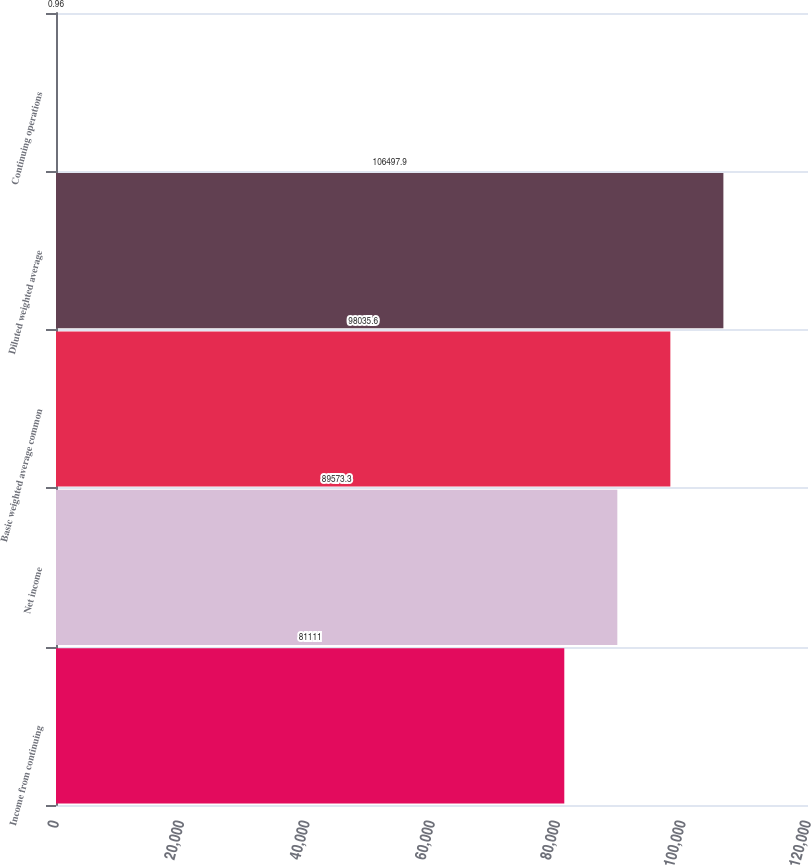Convert chart. <chart><loc_0><loc_0><loc_500><loc_500><bar_chart><fcel>Income from continuing<fcel>Net income<fcel>Basic weighted average common<fcel>Diluted weighted average<fcel>Continuing operations<nl><fcel>81111<fcel>89573.3<fcel>98035.6<fcel>106498<fcel>0.96<nl></chart> 